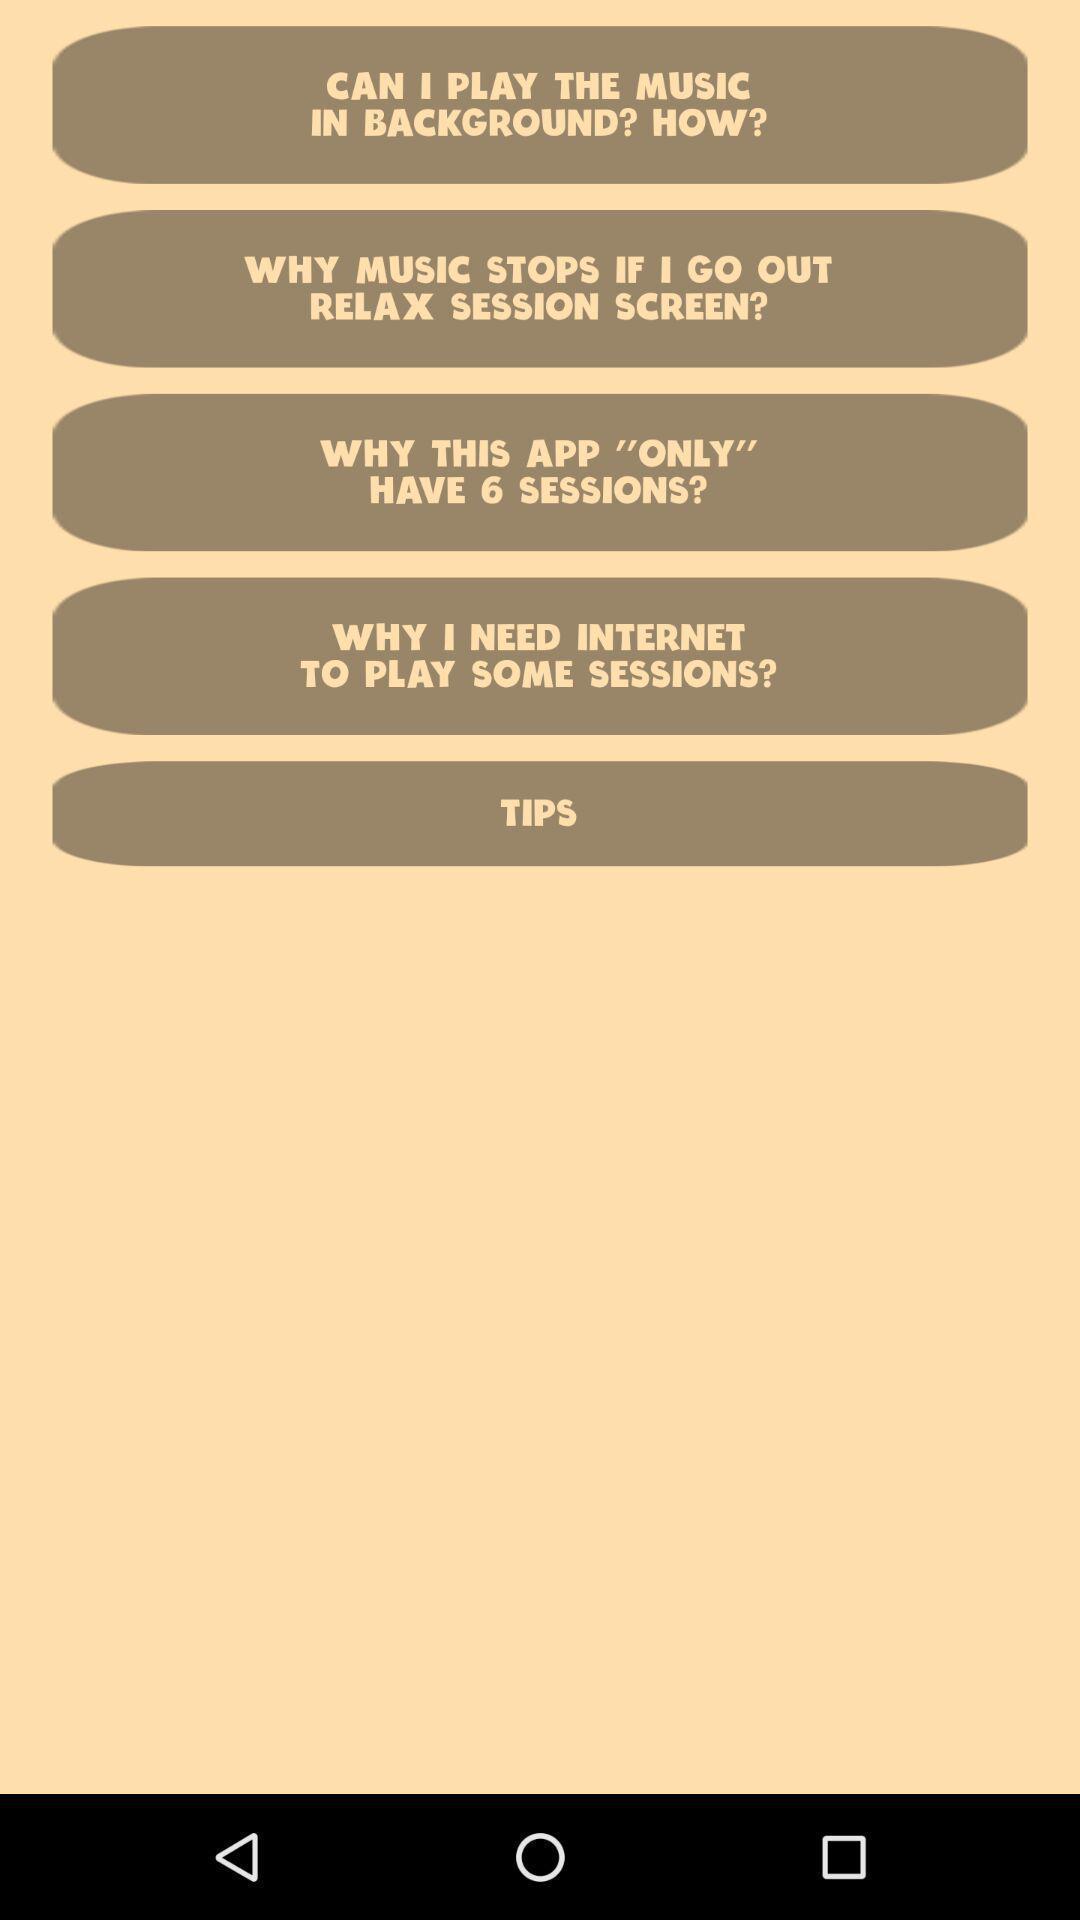Tell me about the visual elements in this screen capture. Screen displaying multiple queries in a music application. 